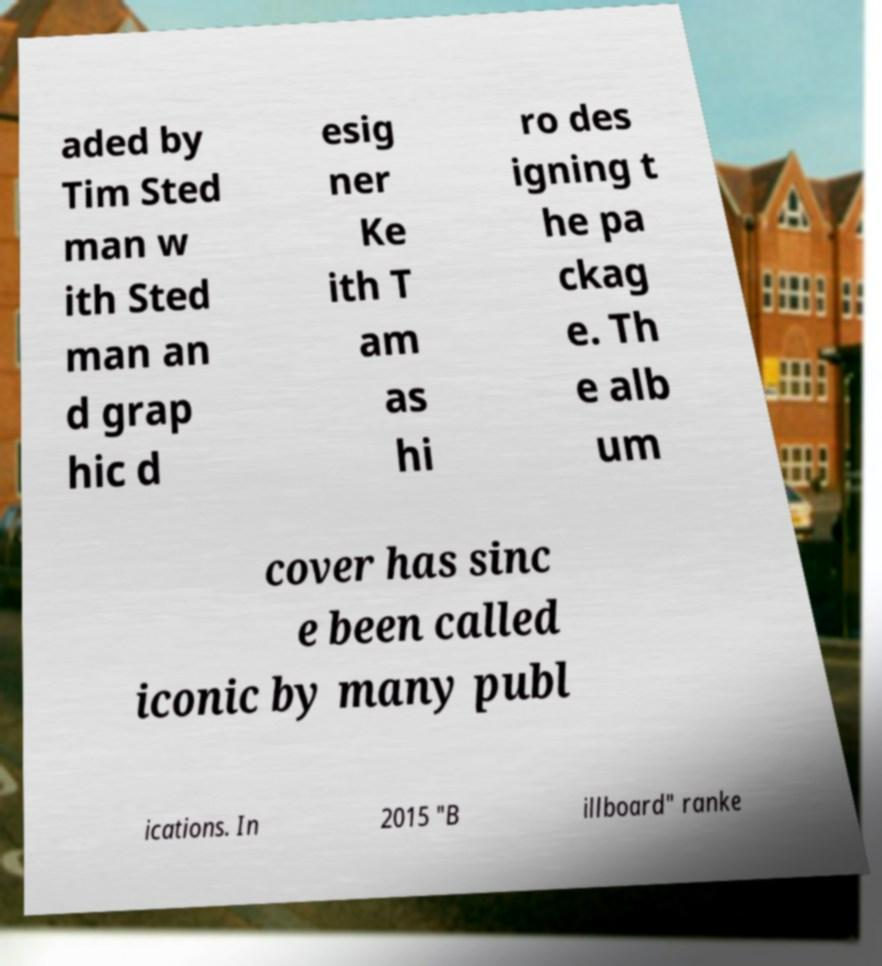What messages or text are displayed in this image? I need them in a readable, typed format. aded by Tim Sted man w ith Sted man an d grap hic d esig ner Ke ith T am as hi ro des igning t he pa ckag e. Th e alb um cover has sinc e been called iconic by many publ ications. In 2015 "B illboard" ranke 